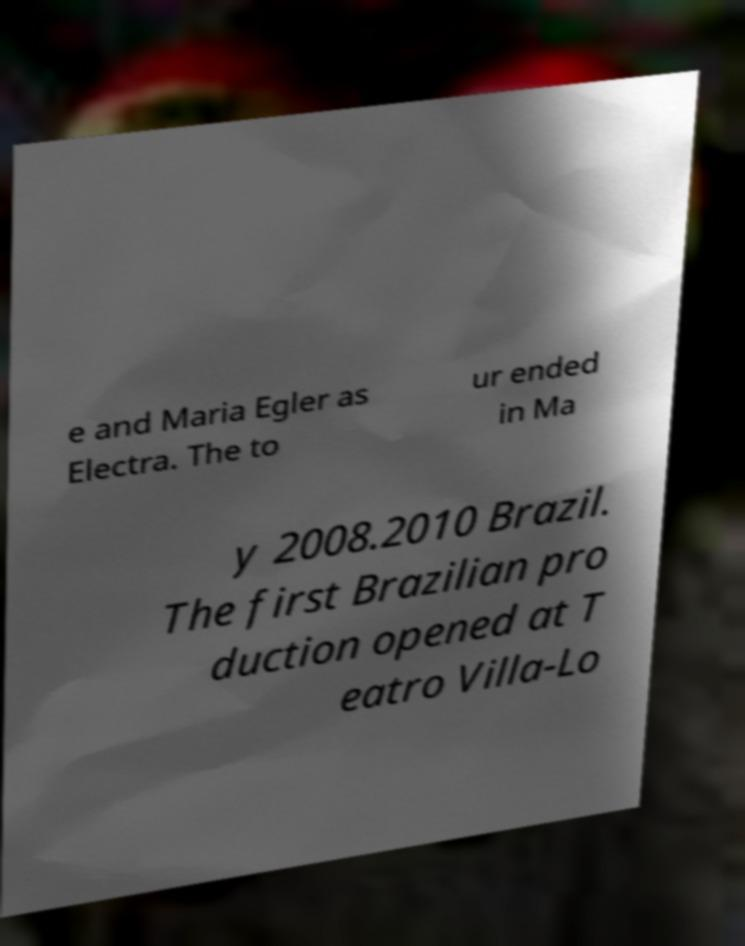Could you assist in decoding the text presented in this image and type it out clearly? e and Maria Egler as Electra. The to ur ended in Ma y 2008.2010 Brazil. The first Brazilian pro duction opened at T eatro Villa-Lo 